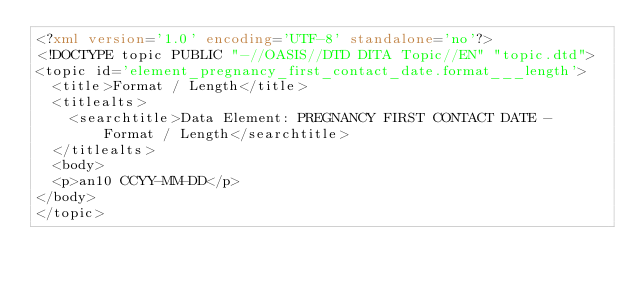Convert code to text. <code><loc_0><loc_0><loc_500><loc_500><_XML_><?xml version='1.0' encoding='UTF-8' standalone='no'?>
<!DOCTYPE topic PUBLIC "-//OASIS//DTD DITA Topic//EN" "topic.dtd">
<topic id='element_pregnancy_first_contact_date.format___length'>
  <title>Format / Length</title>
  <titlealts>
    <searchtitle>Data Element: PREGNANCY FIRST CONTACT DATE - Format / Length</searchtitle>
  </titlealts>
  <body>
  <p>an10 CCYY-MM-DD</p>
</body>
</topic></code> 